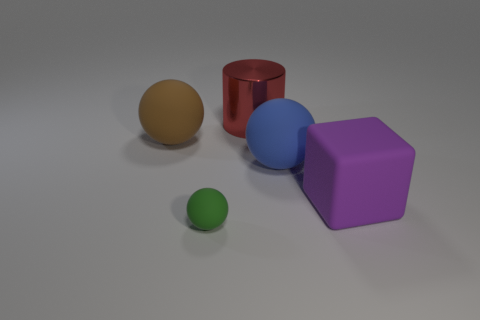Add 4 small green metal balls. How many objects exist? 9 Subtract all cylinders. How many objects are left? 4 Subtract 1 green spheres. How many objects are left? 4 Subtract all small matte objects. Subtract all large brown matte balls. How many objects are left? 3 Add 2 matte things. How many matte things are left? 6 Add 5 big red objects. How many big red objects exist? 6 